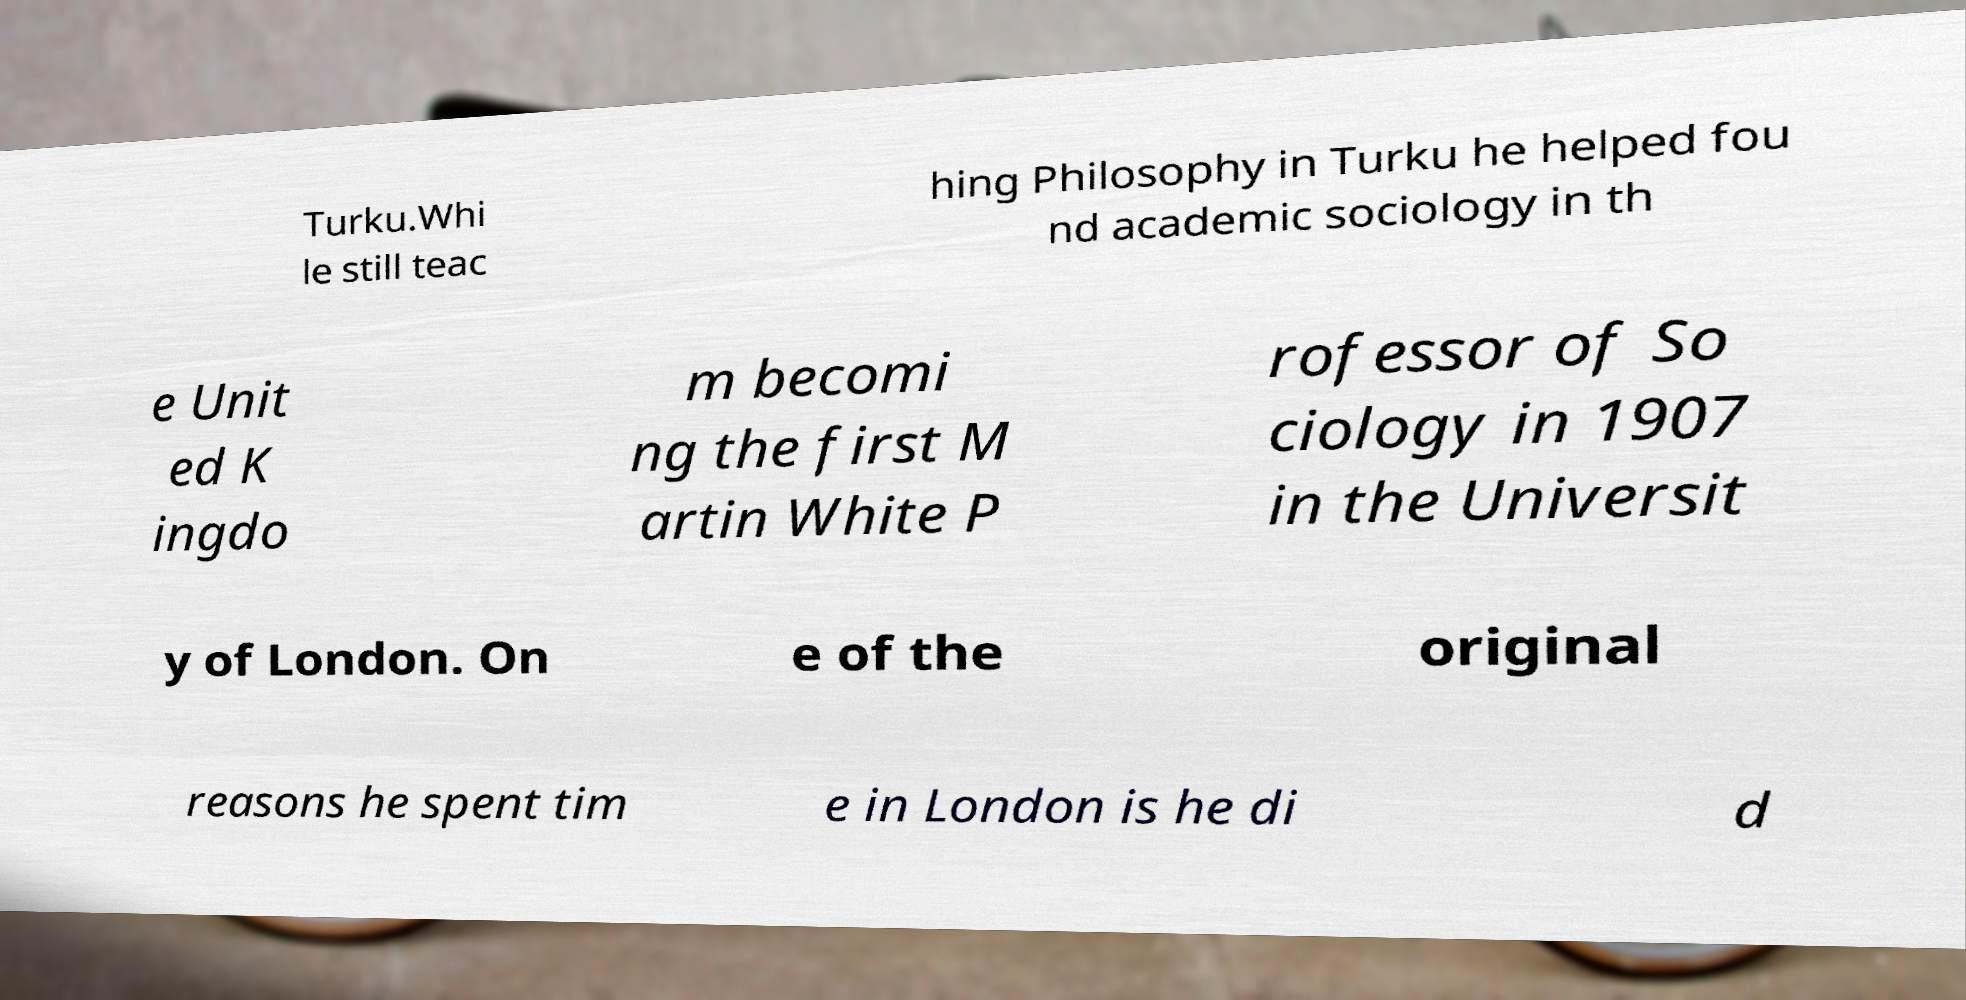Please identify and transcribe the text found in this image. Turku.Whi le still teac hing Philosophy in Turku he helped fou nd academic sociology in th e Unit ed K ingdo m becomi ng the first M artin White P rofessor of So ciology in 1907 in the Universit y of London. On e of the original reasons he spent tim e in London is he di d 